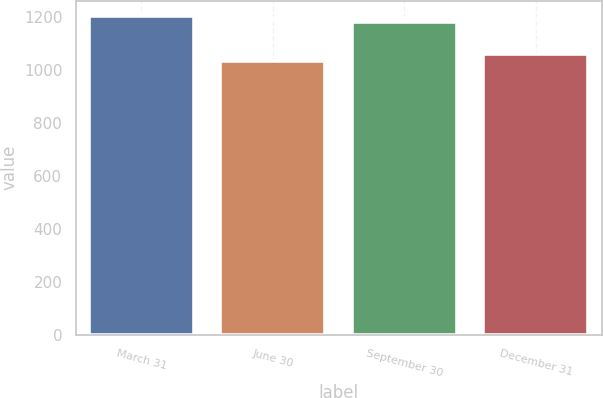Convert chart to OTSL. <chart><loc_0><loc_0><loc_500><loc_500><bar_chart><fcel>March 31<fcel>June 30<fcel>September 30<fcel>December 31<nl><fcel>1202<fcel>1034<fcel>1181<fcel>1062<nl></chart> 